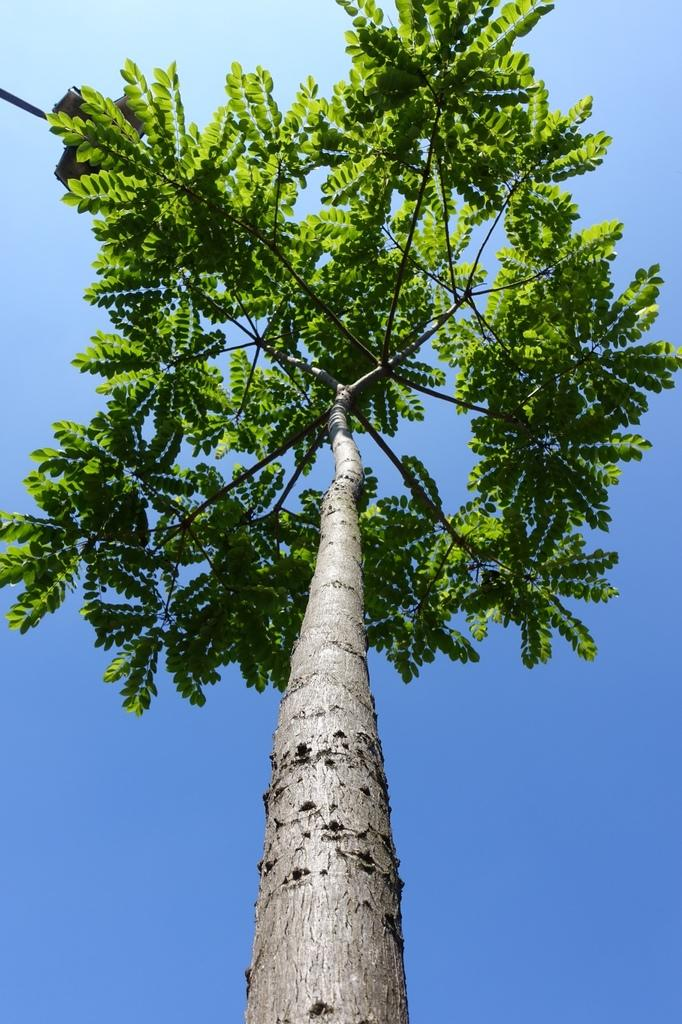What is the main subject in the center of the image? There is a tree in the center of the image. What can be seen in the background of the image? The sky is visible in the background of the image. What type of line is visible in the image? There is no line visible in the image; it features a tree and the sky. What is the airplane's role in the image? There is no airplane present in the image. 